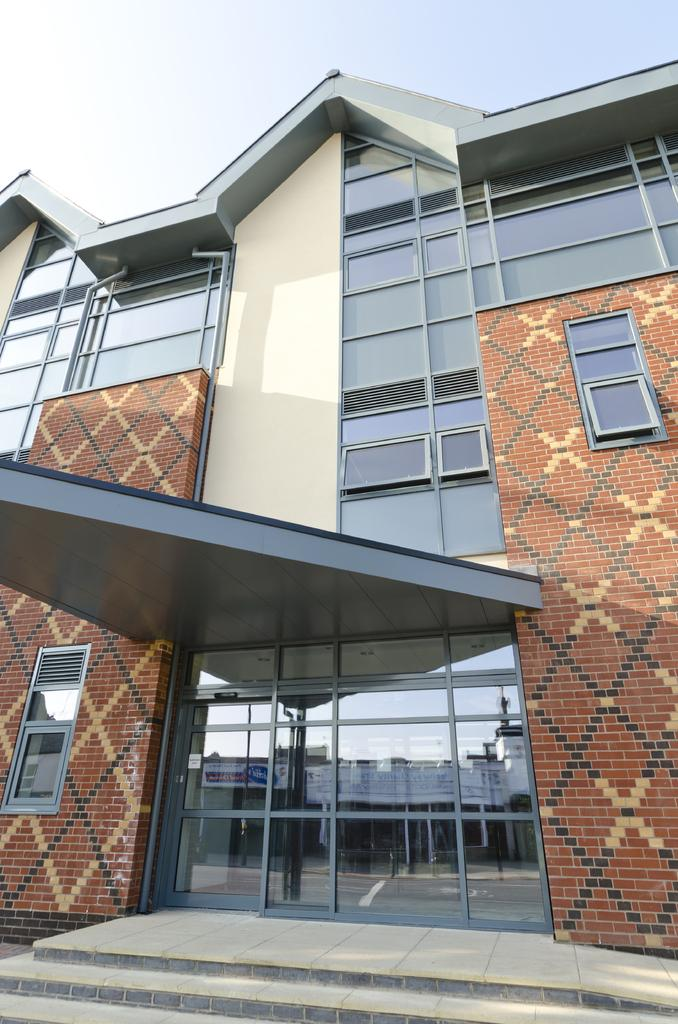What type of structure is visible in the image? There is a building in the image. What is a notable feature of the building? The building has glass panels all over it. Can you describe the location of the building in relation to other structures or objects? The building appears to be in front of other structures or objects. What can be seen above the building in the image? The sky is visible above the building. What type of sweater is draped over the wood in the image? There is no sweater or wood present in the image; it features a building with glass panels. 